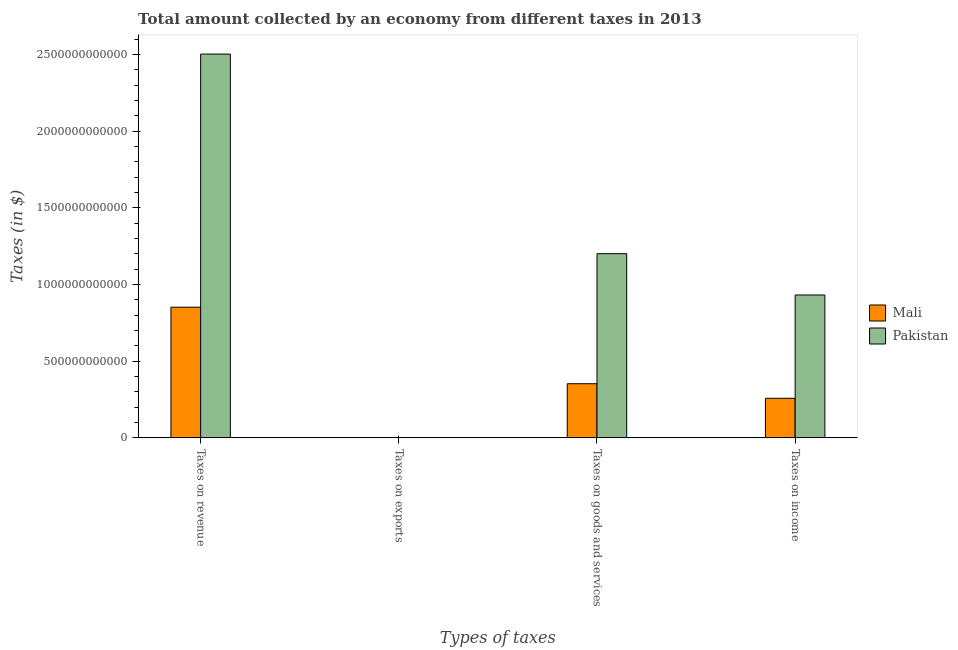How many different coloured bars are there?
Offer a terse response. 2. Are the number of bars per tick equal to the number of legend labels?
Ensure brevity in your answer.  No. How many bars are there on the 3rd tick from the left?
Keep it short and to the point. 2. What is the label of the 2nd group of bars from the left?
Make the answer very short. Taxes on exports. What is the amount collected as tax on goods in Mali?
Ensure brevity in your answer.  3.53e+11. Across all countries, what is the maximum amount collected as tax on income?
Your answer should be compact. 9.32e+11. Across all countries, what is the minimum amount collected as tax on goods?
Offer a terse response. 3.53e+11. What is the total amount collected as tax on revenue in the graph?
Ensure brevity in your answer.  3.36e+12. What is the difference between the amount collected as tax on goods in Pakistan and that in Mali?
Offer a very short reply. 8.48e+11. What is the difference between the amount collected as tax on revenue in Pakistan and the amount collected as tax on income in Mali?
Offer a terse response. 2.25e+12. What is the average amount collected as tax on income per country?
Provide a succinct answer. 5.95e+11. What is the difference between the amount collected as tax on revenue and amount collected as tax on goods in Pakistan?
Keep it short and to the point. 1.30e+12. What is the ratio of the amount collected as tax on income in Pakistan to that in Mali?
Your response must be concise. 3.61. Is the amount collected as tax on goods in Mali less than that in Pakistan?
Make the answer very short. Yes. Is the difference between the amount collected as tax on income in Mali and Pakistan greater than the difference between the amount collected as tax on revenue in Mali and Pakistan?
Your answer should be very brief. Yes. What is the difference between the highest and the second highest amount collected as tax on revenue?
Make the answer very short. 1.65e+12. What is the difference between the highest and the lowest amount collected as tax on goods?
Keep it short and to the point. 8.48e+11. In how many countries, is the amount collected as tax on revenue greater than the average amount collected as tax on revenue taken over all countries?
Your answer should be compact. 1. Is the sum of the amount collected as tax on goods in Mali and Pakistan greater than the maximum amount collected as tax on revenue across all countries?
Your response must be concise. No. Is it the case that in every country, the sum of the amount collected as tax on revenue and amount collected as tax on exports is greater than the amount collected as tax on goods?
Provide a succinct answer. Yes. Are all the bars in the graph horizontal?
Offer a very short reply. No. How many countries are there in the graph?
Provide a succinct answer. 2. What is the difference between two consecutive major ticks on the Y-axis?
Give a very brief answer. 5.00e+11. Are the values on the major ticks of Y-axis written in scientific E-notation?
Provide a succinct answer. No. Does the graph contain any zero values?
Offer a very short reply. Yes. Does the graph contain grids?
Your response must be concise. No. Where does the legend appear in the graph?
Offer a very short reply. Center right. How are the legend labels stacked?
Provide a succinct answer. Vertical. What is the title of the graph?
Give a very brief answer. Total amount collected by an economy from different taxes in 2013. Does "Nepal" appear as one of the legend labels in the graph?
Provide a succinct answer. No. What is the label or title of the X-axis?
Provide a short and direct response. Types of taxes. What is the label or title of the Y-axis?
Keep it short and to the point. Taxes (in $). What is the Taxes (in $) of Mali in Taxes on revenue?
Offer a terse response. 8.52e+11. What is the Taxes (in $) in Pakistan in Taxes on revenue?
Make the answer very short. 2.50e+12. What is the Taxes (in $) of Mali in Taxes on exports?
Your answer should be compact. Nan. What is the Taxes (in $) in Pakistan in Taxes on exports?
Offer a very short reply. Nan. What is the Taxes (in $) of Mali in Taxes on goods and services?
Your response must be concise. 3.53e+11. What is the Taxes (in $) in Pakistan in Taxes on goods and services?
Give a very brief answer. 1.20e+12. What is the Taxes (in $) of Mali in Taxes on income?
Keep it short and to the point. 2.58e+11. What is the Taxes (in $) in Pakistan in Taxes on income?
Offer a very short reply. 9.32e+11. Across all Types of taxes, what is the maximum Taxes (in $) of Mali?
Your response must be concise. 8.52e+11. Across all Types of taxes, what is the maximum Taxes (in $) in Pakistan?
Provide a short and direct response. 2.50e+12. Across all Types of taxes, what is the minimum Taxes (in $) in Mali?
Offer a terse response. 2.58e+11. Across all Types of taxes, what is the minimum Taxes (in $) of Pakistan?
Provide a succinct answer. 9.32e+11. What is the total Taxes (in $) of Mali in the graph?
Provide a short and direct response. 1.46e+12. What is the total Taxes (in $) in Pakistan in the graph?
Offer a very short reply. 4.64e+12. What is the difference between the Taxes (in $) in Mali in Taxes on revenue and that in Taxes on exports?
Offer a terse response. Nan. What is the difference between the Taxes (in $) in Pakistan in Taxes on revenue and that in Taxes on exports?
Make the answer very short. Nan. What is the difference between the Taxes (in $) of Mali in Taxes on revenue and that in Taxes on goods and services?
Your response must be concise. 4.99e+11. What is the difference between the Taxes (in $) in Pakistan in Taxes on revenue and that in Taxes on goods and services?
Your response must be concise. 1.30e+12. What is the difference between the Taxes (in $) in Mali in Taxes on revenue and that in Taxes on income?
Provide a succinct answer. 5.94e+11. What is the difference between the Taxes (in $) of Pakistan in Taxes on revenue and that in Taxes on income?
Give a very brief answer. 1.57e+12. What is the difference between the Taxes (in $) of Mali in Taxes on exports and that in Taxes on goods and services?
Provide a succinct answer. Nan. What is the difference between the Taxes (in $) in Pakistan in Taxes on exports and that in Taxes on goods and services?
Keep it short and to the point. Nan. What is the difference between the Taxes (in $) of Mali in Taxes on exports and that in Taxes on income?
Offer a terse response. Nan. What is the difference between the Taxes (in $) of Pakistan in Taxes on exports and that in Taxes on income?
Offer a terse response. Nan. What is the difference between the Taxes (in $) in Mali in Taxes on goods and services and that in Taxes on income?
Provide a succinct answer. 9.50e+1. What is the difference between the Taxes (in $) in Pakistan in Taxes on goods and services and that in Taxes on income?
Provide a short and direct response. 2.70e+11. What is the difference between the Taxes (in $) of Mali in Taxes on revenue and the Taxes (in $) of Pakistan in Taxes on exports?
Offer a terse response. Nan. What is the difference between the Taxes (in $) of Mali in Taxes on revenue and the Taxes (in $) of Pakistan in Taxes on goods and services?
Give a very brief answer. -3.49e+11. What is the difference between the Taxes (in $) in Mali in Taxes on revenue and the Taxes (in $) in Pakistan in Taxes on income?
Offer a terse response. -7.96e+1. What is the difference between the Taxes (in $) of Mali in Taxes on exports and the Taxes (in $) of Pakistan in Taxes on goods and services?
Your response must be concise. Nan. What is the difference between the Taxes (in $) in Mali in Taxes on exports and the Taxes (in $) in Pakistan in Taxes on income?
Ensure brevity in your answer.  Nan. What is the difference between the Taxes (in $) in Mali in Taxes on goods and services and the Taxes (in $) in Pakistan in Taxes on income?
Your response must be concise. -5.79e+11. What is the average Taxes (in $) in Mali per Types of taxes?
Offer a very short reply. 3.66e+11. What is the average Taxes (in $) in Pakistan per Types of taxes?
Offer a very short reply. 1.16e+12. What is the difference between the Taxes (in $) of Mali and Taxes (in $) of Pakistan in Taxes on revenue?
Provide a short and direct response. -1.65e+12. What is the difference between the Taxes (in $) in Mali and Taxes (in $) in Pakistan in Taxes on exports?
Your answer should be compact. Nan. What is the difference between the Taxes (in $) of Mali and Taxes (in $) of Pakistan in Taxes on goods and services?
Provide a succinct answer. -8.48e+11. What is the difference between the Taxes (in $) in Mali and Taxes (in $) in Pakistan in Taxes on income?
Keep it short and to the point. -6.74e+11. What is the ratio of the Taxes (in $) of Mali in Taxes on revenue to that in Taxes on exports?
Your answer should be compact. Nan. What is the ratio of the Taxes (in $) in Pakistan in Taxes on revenue to that in Taxes on exports?
Your response must be concise. Nan. What is the ratio of the Taxes (in $) of Mali in Taxes on revenue to that in Taxes on goods and services?
Make the answer very short. 2.41. What is the ratio of the Taxes (in $) of Pakistan in Taxes on revenue to that in Taxes on goods and services?
Keep it short and to the point. 2.08. What is the ratio of the Taxes (in $) of Mali in Taxes on revenue to that in Taxes on income?
Offer a terse response. 3.3. What is the ratio of the Taxes (in $) in Pakistan in Taxes on revenue to that in Taxes on income?
Ensure brevity in your answer.  2.69. What is the ratio of the Taxes (in $) of Mali in Taxes on exports to that in Taxes on goods and services?
Make the answer very short. Nan. What is the ratio of the Taxes (in $) in Pakistan in Taxes on exports to that in Taxes on goods and services?
Offer a very short reply. Nan. What is the ratio of the Taxes (in $) in Mali in Taxes on exports to that in Taxes on income?
Your answer should be compact. Nan. What is the ratio of the Taxes (in $) in Pakistan in Taxes on exports to that in Taxes on income?
Your answer should be very brief. Nan. What is the ratio of the Taxes (in $) of Mali in Taxes on goods and services to that in Taxes on income?
Ensure brevity in your answer.  1.37. What is the ratio of the Taxes (in $) in Pakistan in Taxes on goods and services to that in Taxes on income?
Make the answer very short. 1.29. What is the difference between the highest and the second highest Taxes (in $) of Mali?
Make the answer very short. 4.99e+11. What is the difference between the highest and the second highest Taxes (in $) of Pakistan?
Your response must be concise. 1.30e+12. What is the difference between the highest and the lowest Taxes (in $) of Mali?
Keep it short and to the point. 5.94e+11. What is the difference between the highest and the lowest Taxes (in $) of Pakistan?
Your response must be concise. 1.57e+12. 